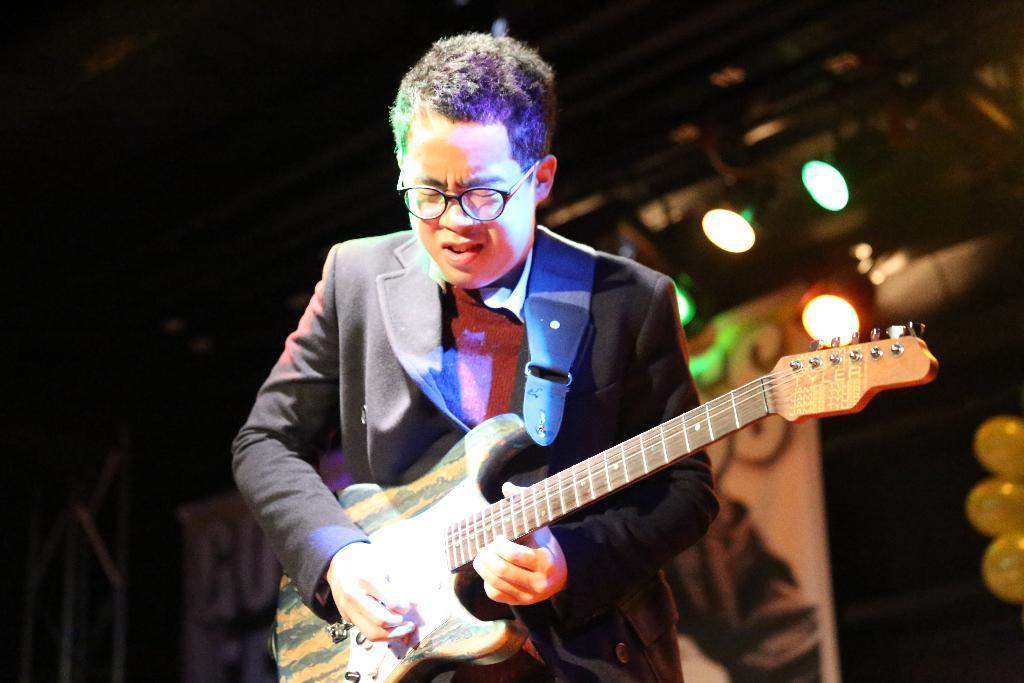How would you summarize this image in a sentence or two? In the image we can see there is a man who is standing and holding guitar in his hand. 